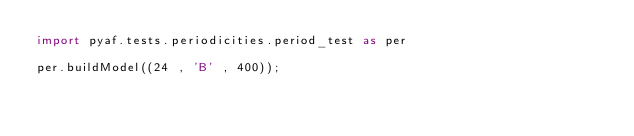Convert code to text. <code><loc_0><loc_0><loc_500><loc_500><_Python_>import pyaf.tests.periodicities.period_test as per

per.buildModel((24 , 'B' , 400));

</code> 